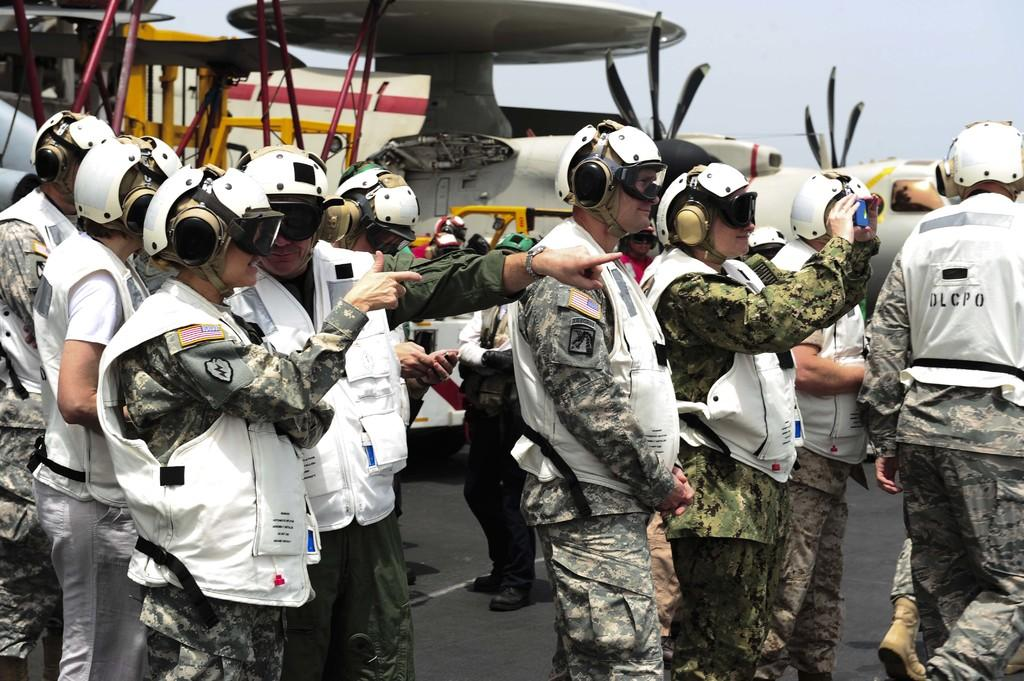How many people are in the image? There are many people in the image. What protective gear are the people wearing? The people are wearing helmets, headphones, goggles, and white jackets. What can be seen in the background of the image? There are aircrafts and the sky visible in the background. What type of corn is being balanced on the people's heads in the image? There is no corn present in the image, and the people are not balancing anything on their heads. 